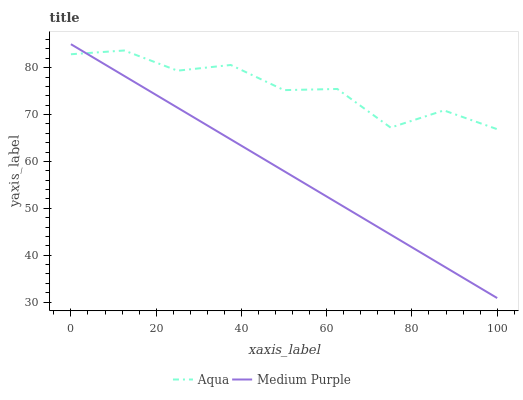Does Medium Purple have the minimum area under the curve?
Answer yes or no. Yes. Does Aqua have the maximum area under the curve?
Answer yes or no. Yes. Does Aqua have the minimum area under the curve?
Answer yes or no. No. Is Medium Purple the smoothest?
Answer yes or no. Yes. Is Aqua the roughest?
Answer yes or no. Yes. Is Aqua the smoothest?
Answer yes or no. No. Does Medium Purple have the lowest value?
Answer yes or no. Yes. Does Aqua have the lowest value?
Answer yes or no. No. Does Medium Purple have the highest value?
Answer yes or no. Yes. Does Aqua have the highest value?
Answer yes or no. No. Does Aqua intersect Medium Purple?
Answer yes or no. Yes. Is Aqua less than Medium Purple?
Answer yes or no. No. Is Aqua greater than Medium Purple?
Answer yes or no. No. 